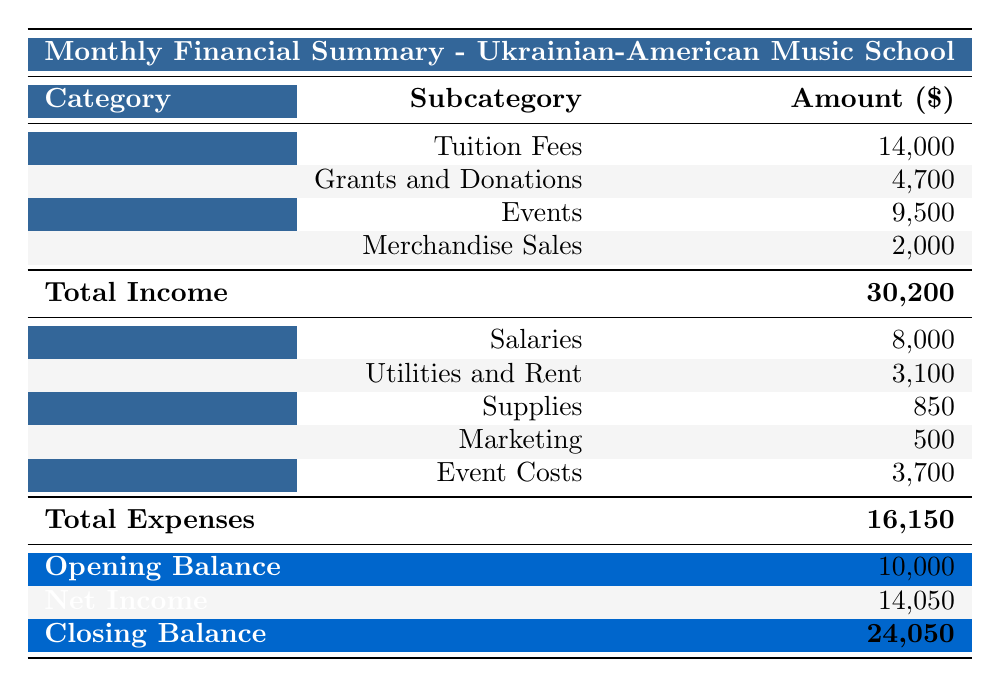What is the total income for the Ukrainian-American Music School? The "Total Income" row in the table shows the total amount earned by the school, which is provided directly as $30,200.
Answer: 30,200 What is the total expense incurred by the school? The "Total Expenses" row indicates the total cost incurred, which is given as $16,150.
Answer: 16,150 How much money did the school make from events? To find the income from events, we sum the amounts listed under the "Events" category: $3,000 (Annual Recital) + $2,500 (Cultural Festival) + $4,000 (Charity Concert) = $9,500.
Answer: 9,500 Is the total income greater than the total expenses? Yes, comparing the "Total Income" of $30,200 with the "Total Expenses" of $16,150, the income exceeds the expenses.
Answer: Yes What is the closing balance for the month? The "Closing Balance" row explicitly states that the final balance for the month is $24,050.
Answer: 24,050 What percentage of the total income is attributed to tuition fees? The amount from tuition fees is $14,000. To find the percentage, we calculate (14,000 / 30,200) * 100 = 46.3%.
Answer: 46.3% What is the combined amount spent on utilities and rent? We add the amounts listed under "Utilities and Rent": Rent ($2,500) + Electricity ($300) + Water ($200) + Internet ($100) = $3,100.
Answer: 3,100 Did the school receive more money from grants and donations or from merchandise sales? The table shows $4,700 as the total from grants and donations and $2,000 from merchandise sales. Since 4,700 is greater than 2,000, the answer is grants and donations.
Answer: Grants and donations What is the net income for the Ukrainian-American Music School? To find the net income, we subtract total expenses from total income: $30,200 (Total Income) - $16,150 (Total Expenses) = $14,050.
Answer: 14,050 